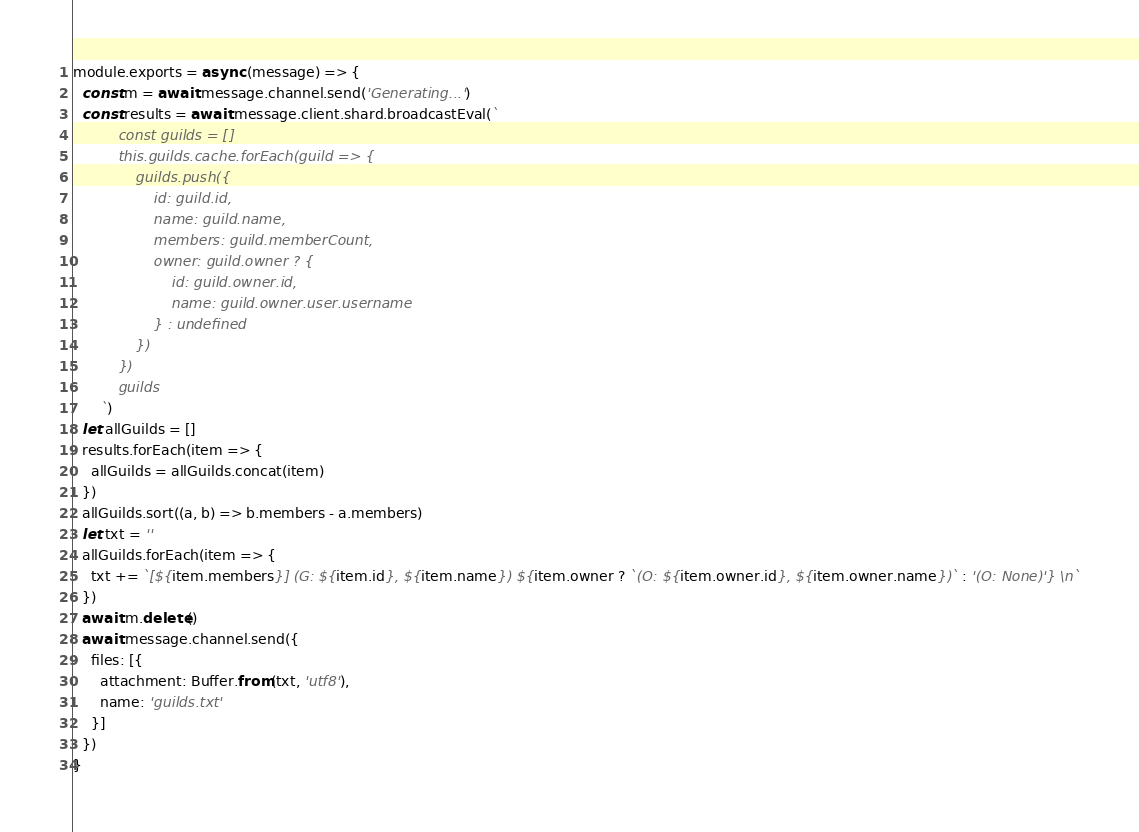<code> <loc_0><loc_0><loc_500><loc_500><_JavaScript_>module.exports = async (message) => {
  const m = await message.channel.send('Generating...')
  const results = await message.client.shard.broadcastEval(`
          const guilds = []
          this.guilds.cache.forEach(guild => {
              guilds.push({
                  id: guild.id,
                  name: guild.name,
                  members: guild.memberCount,
                  owner: guild.owner ? {
                      id: guild.owner.id,
                      name: guild.owner.user.username
                  } : undefined
              })
          })
          guilds
      `)
  let allGuilds = []
  results.forEach(item => {
    allGuilds = allGuilds.concat(item)
  })
  allGuilds.sort((a, b) => b.members - a.members)
  let txt = ''
  allGuilds.forEach(item => {
    txt += `[${item.members}] (G: ${item.id}, ${item.name}) ${item.owner ? `(O: ${item.owner.id}, ${item.owner.name})` : '(O: None)'} \n`
  })
  await m.delete()
  await message.channel.send({
    files: [{
      attachment: Buffer.from(txt, 'utf8'),
      name: 'guilds.txt'
    }]
  })
}
</code> 